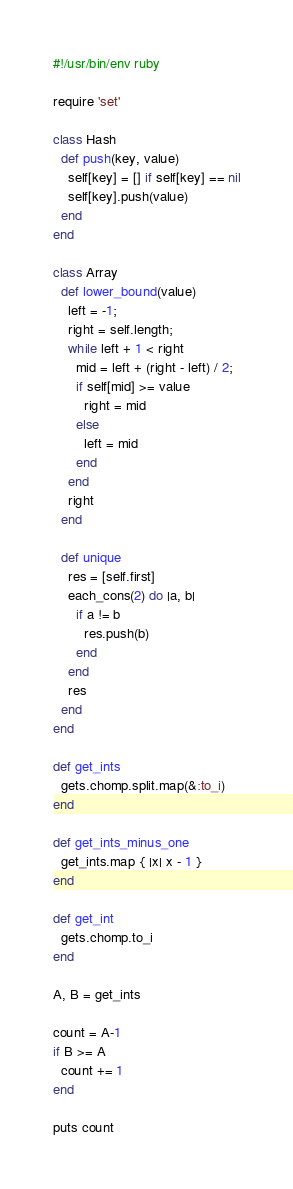<code> <loc_0><loc_0><loc_500><loc_500><_Ruby_>#!/usr/bin/env ruby

require 'set'

class Hash
  def push(key, value)
    self[key] = [] if self[key] == nil
    self[key].push(value)
  end
end

class Array
  def lower_bound(value)
    left = -1;
    right = self.length;
    while left + 1 < right
      mid = left + (right - left) / 2;
      if self[mid] >= value
        right = mid
      else
        left = mid
      end
    end
    right
  end

  def unique
    res = [self.first]
    each_cons(2) do |a, b|
      if a != b
        res.push(b)
      end
    end
    res
  end
end

def get_ints
  gets.chomp.split.map(&:to_i)
end

def get_ints_minus_one
  get_ints.map { |x| x - 1 }
end

def get_int
  gets.chomp.to_i
end

A, B = get_ints

count = A-1
if B >= A
  count += 1
end

puts count
</code> 